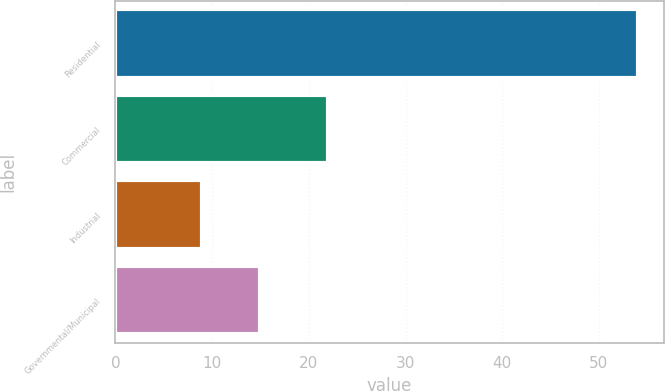Convert chart to OTSL. <chart><loc_0><loc_0><loc_500><loc_500><bar_chart><fcel>Residential<fcel>Commercial<fcel>Industrial<fcel>Governmental/Municipal<nl><fcel>54<fcel>22<fcel>9<fcel>15<nl></chart> 